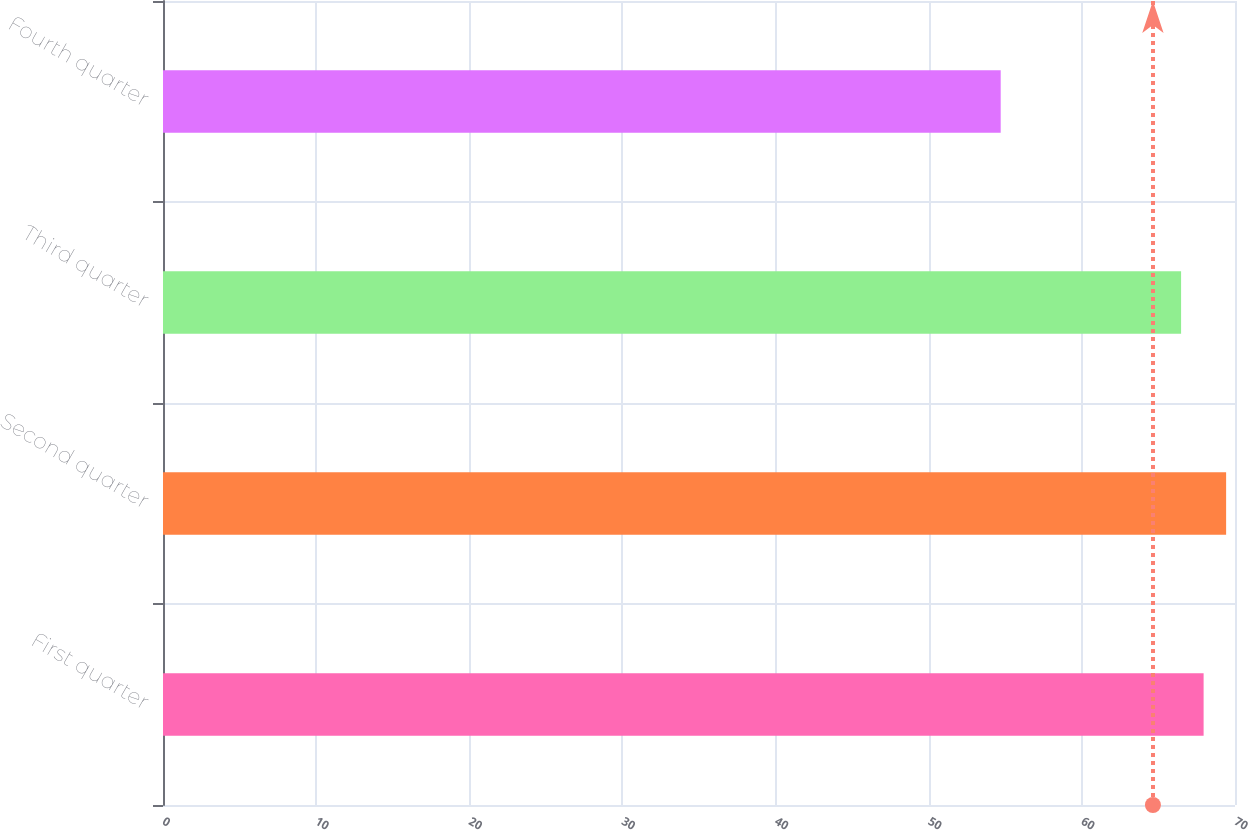<chart> <loc_0><loc_0><loc_500><loc_500><bar_chart><fcel>First quarter<fcel>Second quarter<fcel>Third quarter<fcel>Fourth quarter<nl><fcel>67.95<fcel>69.42<fcel>66.48<fcel>54.7<nl></chart> 